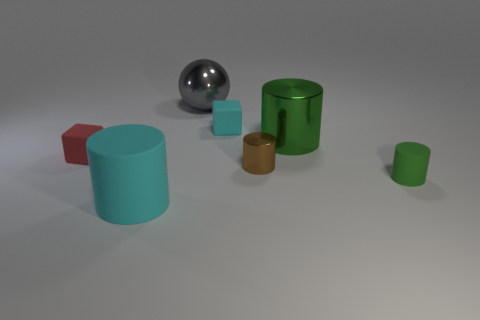Subtract all tiny matte cylinders. How many cylinders are left? 3 Subtract all purple balls. How many green cylinders are left? 2 Subtract all brown cylinders. How many cylinders are left? 3 Subtract all blue cylinders. Subtract all cyan cubes. How many cylinders are left? 4 Add 3 tiny brown rubber things. How many objects exist? 10 Subtract all cylinders. How many objects are left? 3 Subtract 0 gray cylinders. How many objects are left? 7 Subtract all small brown cylinders. Subtract all small things. How many objects are left? 2 Add 5 tiny cyan objects. How many tiny cyan objects are left? 6 Add 3 small brown objects. How many small brown objects exist? 4 